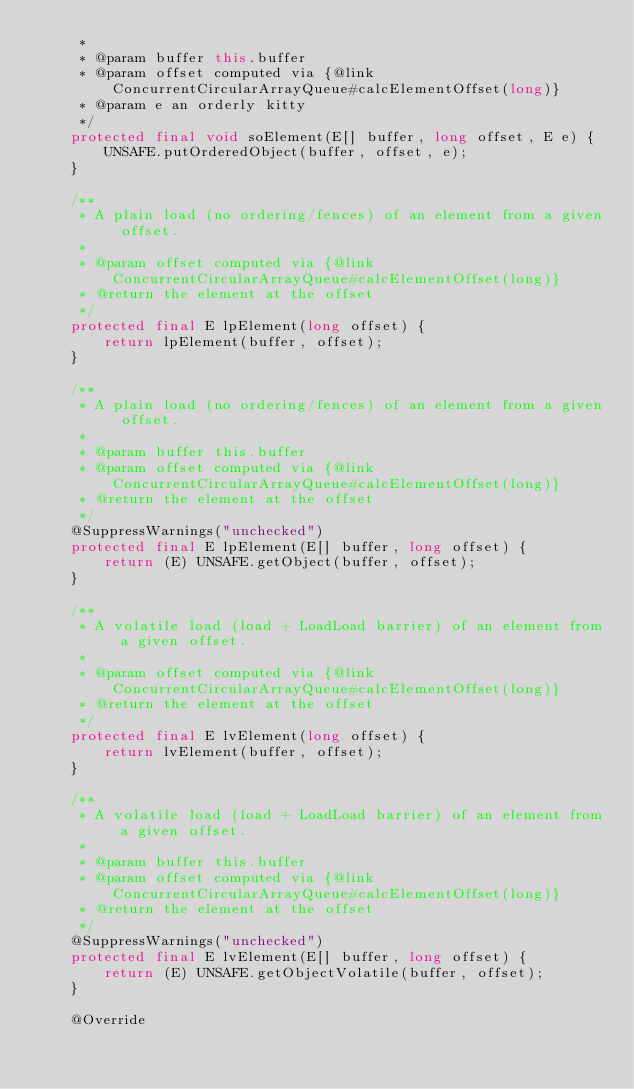<code> <loc_0><loc_0><loc_500><loc_500><_Java_>     *
     * @param buffer this.buffer
     * @param offset computed via {@link ConcurrentCircularArrayQueue#calcElementOffset(long)}
     * @param e an orderly kitty
     */
    protected final void soElement(E[] buffer, long offset, E e) {
        UNSAFE.putOrderedObject(buffer, offset, e);
    }

    /**
     * A plain load (no ordering/fences) of an element from a given offset.
     *
     * @param offset computed via {@link ConcurrentCircularArrayQueue#calcElementOffset(long)}
     * @return the element at the offset
     */
    protected final E lpElement(long offset) {
        return lpElement(buffer, offset);
    }

    /**
     * A plain load (no ordering/fences) of an element from a given offset.
     *
     * @param buffer this.buffer
     * @param offset computed via {@link ConcurrentCircularArrayQueue#calcElementOffset(long)}
     * @return the element at the offset
     */
    @SuppressWarnings("unchecked")
    protected final E lpElement(E[] buffer, long offset) {
        return (E) UNSAFE.getObject(buffer, offset);
    }

    /**
     * A volatile load (load + LoadLoad barrier) of an element from a given offset.
     *
     * @param offset computed via {@link ConcurrentCircularArrayQueue#calcElementOffset(long)}
     * @return the element at the offset
     */
    protected final E lvElement(long offset) {
        return lvElement(buffer, offset);
    }

    /**
     * A volatile load (load + LoadLoad barrier) of an element from a given offset.
     *
     * @param buffer this.buffer
     * @param offset computed via {@link ConcurrentCircularArrayQueue#calcElementOffset(long)}
     * @return the element at the offset
     */
    @SuppressWarnings("unchecked")
    protected final E lvElement(E[] buffer, long offset) {
        return (E) UNSAFE.getObjectVolatile(buffer, offset);
    }

    @Override</code> 